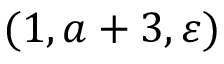Convert formula to latex. <formula><loc_0><loc_0><loc_500><loc_500>( 1 , a + 3 , \varepsilon )</formula> 